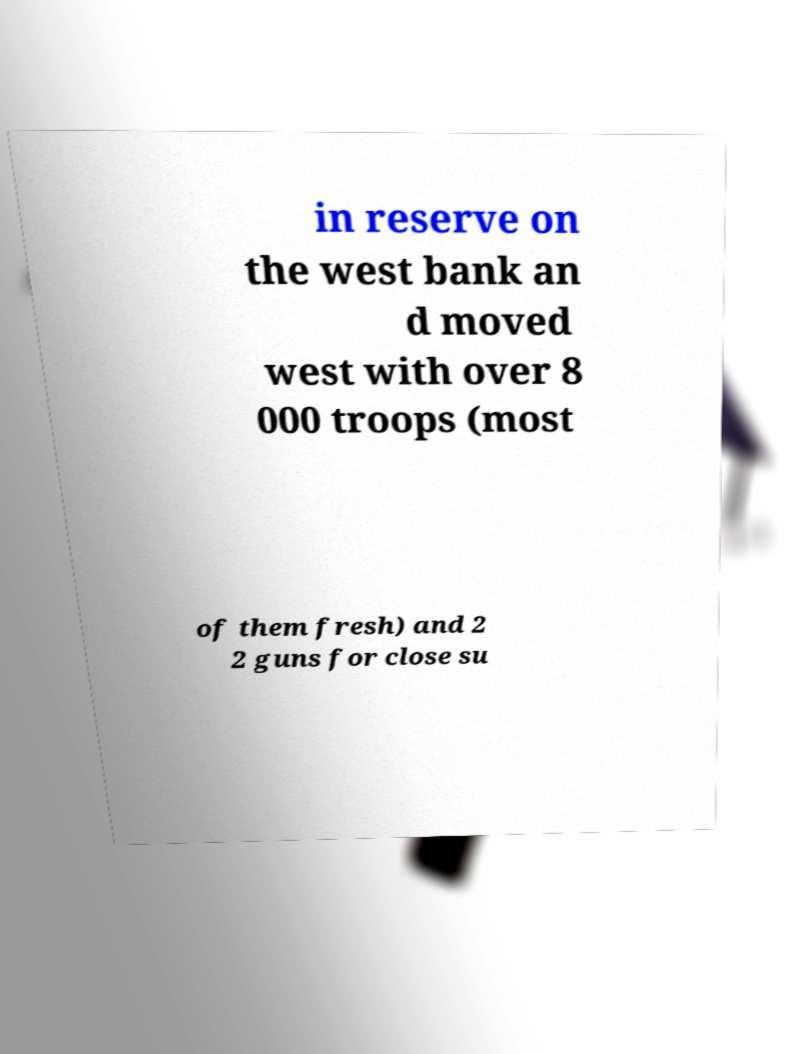Could you assist in decoding the text presented in this image and type it out clearly? in reserve on the west bank an d moved west with over 8 000 troops (most of them fresh) and 2 2 guns for close su 